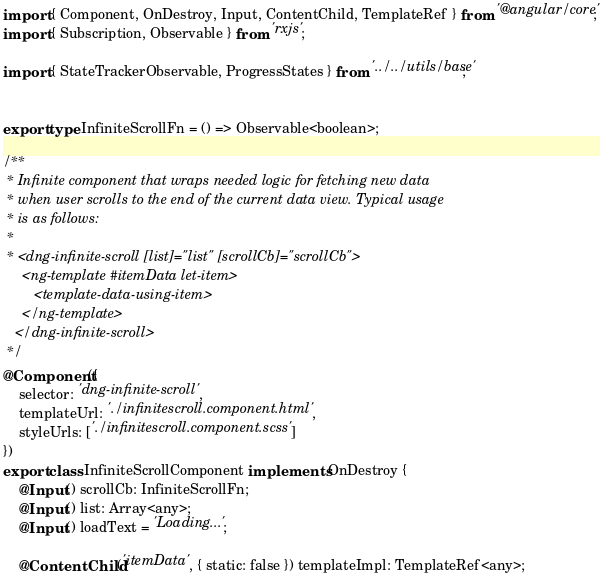Convert code to text. <code><loc_0><loc_0><loc_500><loc_500><_TypeScript_>import { Component, OnDestroy, Input, ContentChild, TemplateRef } from '@angular/core';
import { Subscription, Observable } from 'rxjs';

import { StateTrackerObservable, ProgressStates } from '../../utils/base';


export type InfiniteScrollFn = () => Observable<boolean>;

/**
 * Infinite component that wraps needed logic for fetching new data
 * when user scrolls to the end of the current data view. Typical usage
 * is as follows:
 *
 * <dng-infinite-scroll [list]="list" [scrollCb]="scrollCb">
     <ng-template #itemData let-item>
        <template-data-using-item>
     </ng-template>
   </dng-infinite-scroll>
 */
@Component({
    selector: 'dng-infinite-scroll',
    templateUrl: './infinitescroll.component.html',
    styleUrls: ['./infinitescroll.component.scss']
})
export class InfiniteScrollComponent implements OnDestroy {
    @Input() scrollCb: InfiniteScrollFn;
    @Input() list: Array<any>;
    @Input() loadText = 'Loading...';

    @ContentChild('itemData', { static: false }) templateImpl: TemplateRef<any>;
</code> 